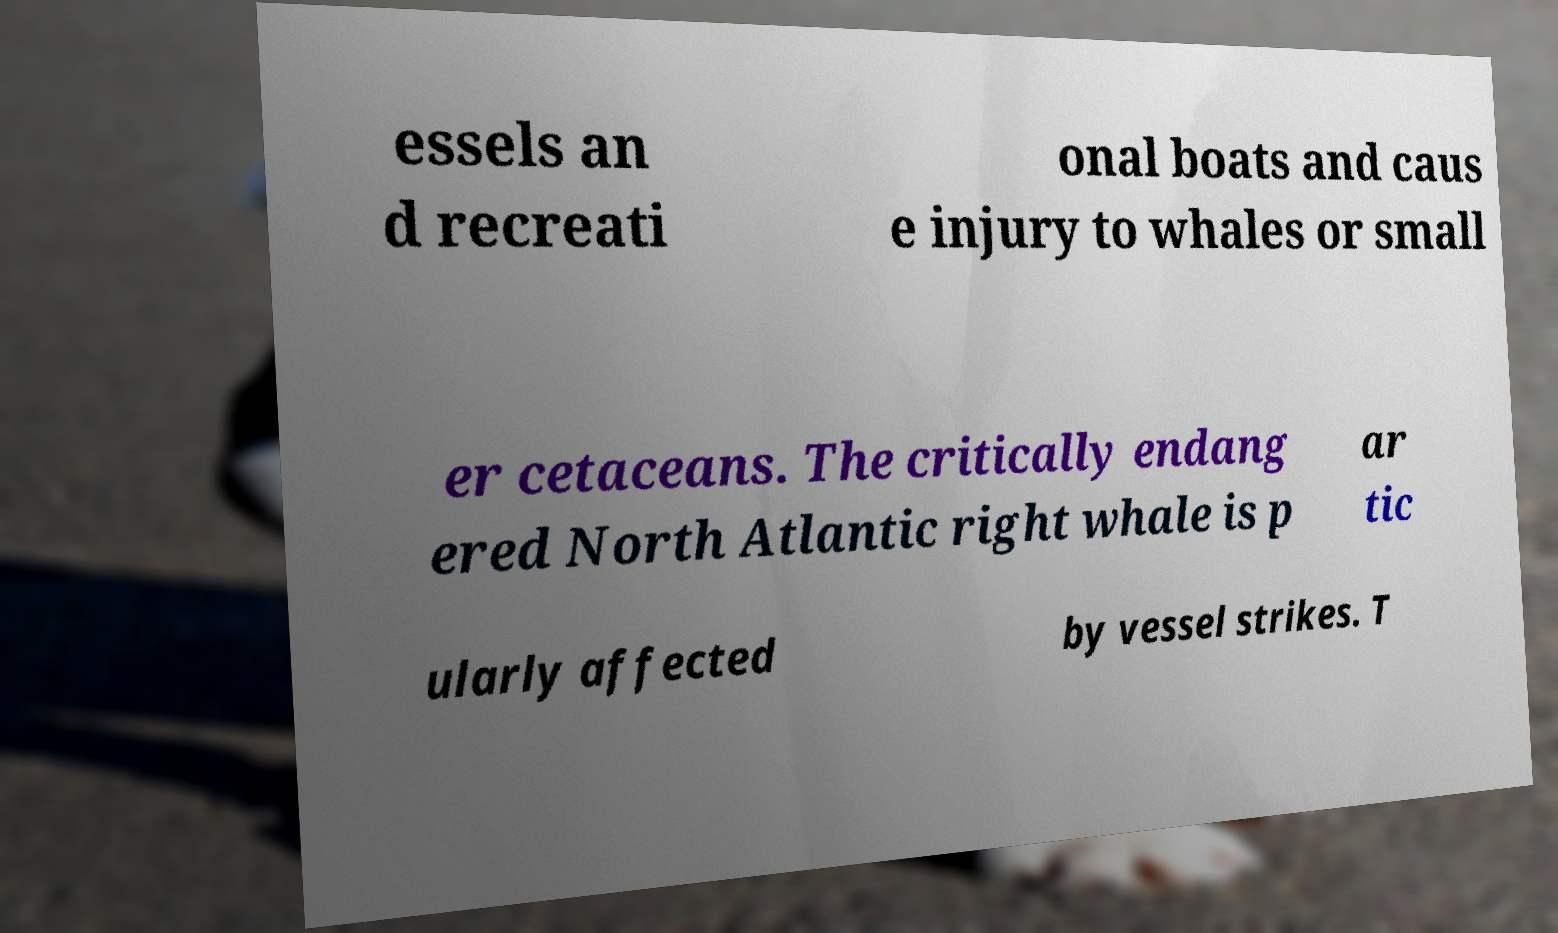Please read and relay the text visible in this image. What does it say? essels an d recreati onal boats and caus e injury to whales or small er cetaceans. The critically endang ered North Atlantic right whale is p ar tic ularly affected by vessel strikes. T 